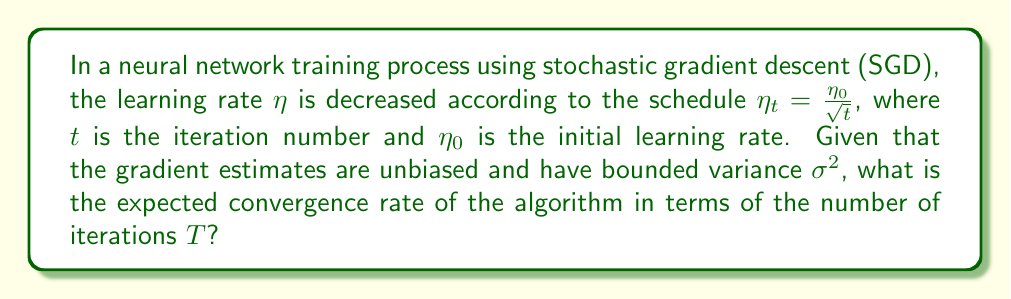Can you solve this math problem? To analyze the convergence rate of SGD in this scenario, we'll follow these steps:

1) For SGD with decreasing learning rate, the general convergence rate is given by:

   $$\mathbb{E}[f(x_T) - f(x^*)] \leq O\left(\frac{1}{\sum_{t=1}^T \eta_t} + \frac{\sum_{t=1}^T \eta_t^2}{2\sum_{t=1}^T \eta_t}\right)$$

   where $f(x_T)$ is the loss after $T$ iterations, and $f(x^*)$ is the optimal loss.

2) Substituting our learning rate schedule $\eta_t = \frac{\eta_0}{\sqrt{t}}$:

   $$\mathbb{E}[f(x_T) - f(x^*)] \leq O\left(\frac{1}{\sum_{t=1}^T \frac{\eta_0}{\sqrt{t}}} + \frac{\sum_{t=1}^T \frac{\eta_0^2}{t}}{2\sum_{t=1}^T \frac{\eta_0}{\sqrt{t}}}\right)$$

3) We can approximate the sums using integrals:

   $$\sum_{t=1}^T \frac{1}{\sqrt{t}} \approx 2\sqrt{T} - 1$$
   $$\sum_{t=1}^T \frac{1}{t} \approx \log T$$

4) Substituting these approximations:

   $$\mathbb{E}[f(x_T) - f(x^*)] \leq O\left(\frac{1}{2\eta_0\sqrt{T}} + \frac{\eta_0\log T}{4\sqrt{T}}\right)$$

5) The dominant term as $T \to \infty$ is $\frac{1}{\sqrt{T}}$, so we can simplify:

   $$\mathbb{E}[f(x_T) - f(x^*)] \leq O\left(\frac{1}{\sqrt{T}}\right)$$

This means the algorithm converges at a rate of $O(\frac{1}{\sqrt{T}})$.
Answer: $O(\frac{1}{\sqrt{T}})$ 